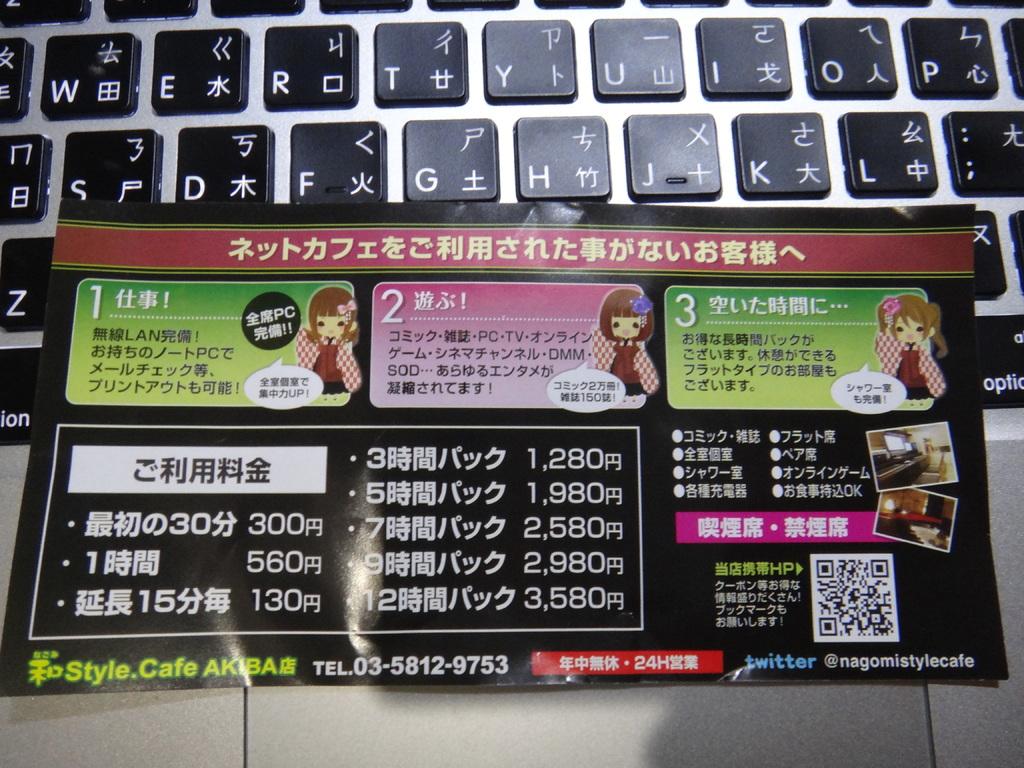What is the telephone number on the bottom?
Provide a short and direct response. 03-5812-9753. 